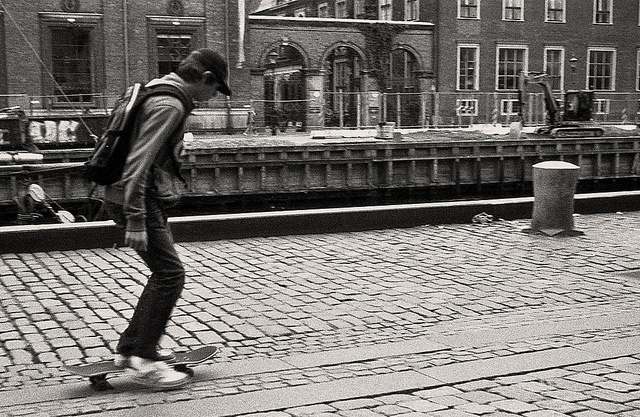Describe the objects in this image and their specific colors. I can see people in gray, black, darkgray, and lightgray tones, backpack in gray, black, darkgray, and lightgray tones, skateboard in gray, black, darkgray, and lightgray tones, and people in gray, darkgray, black, and lightgray tones in this image. 